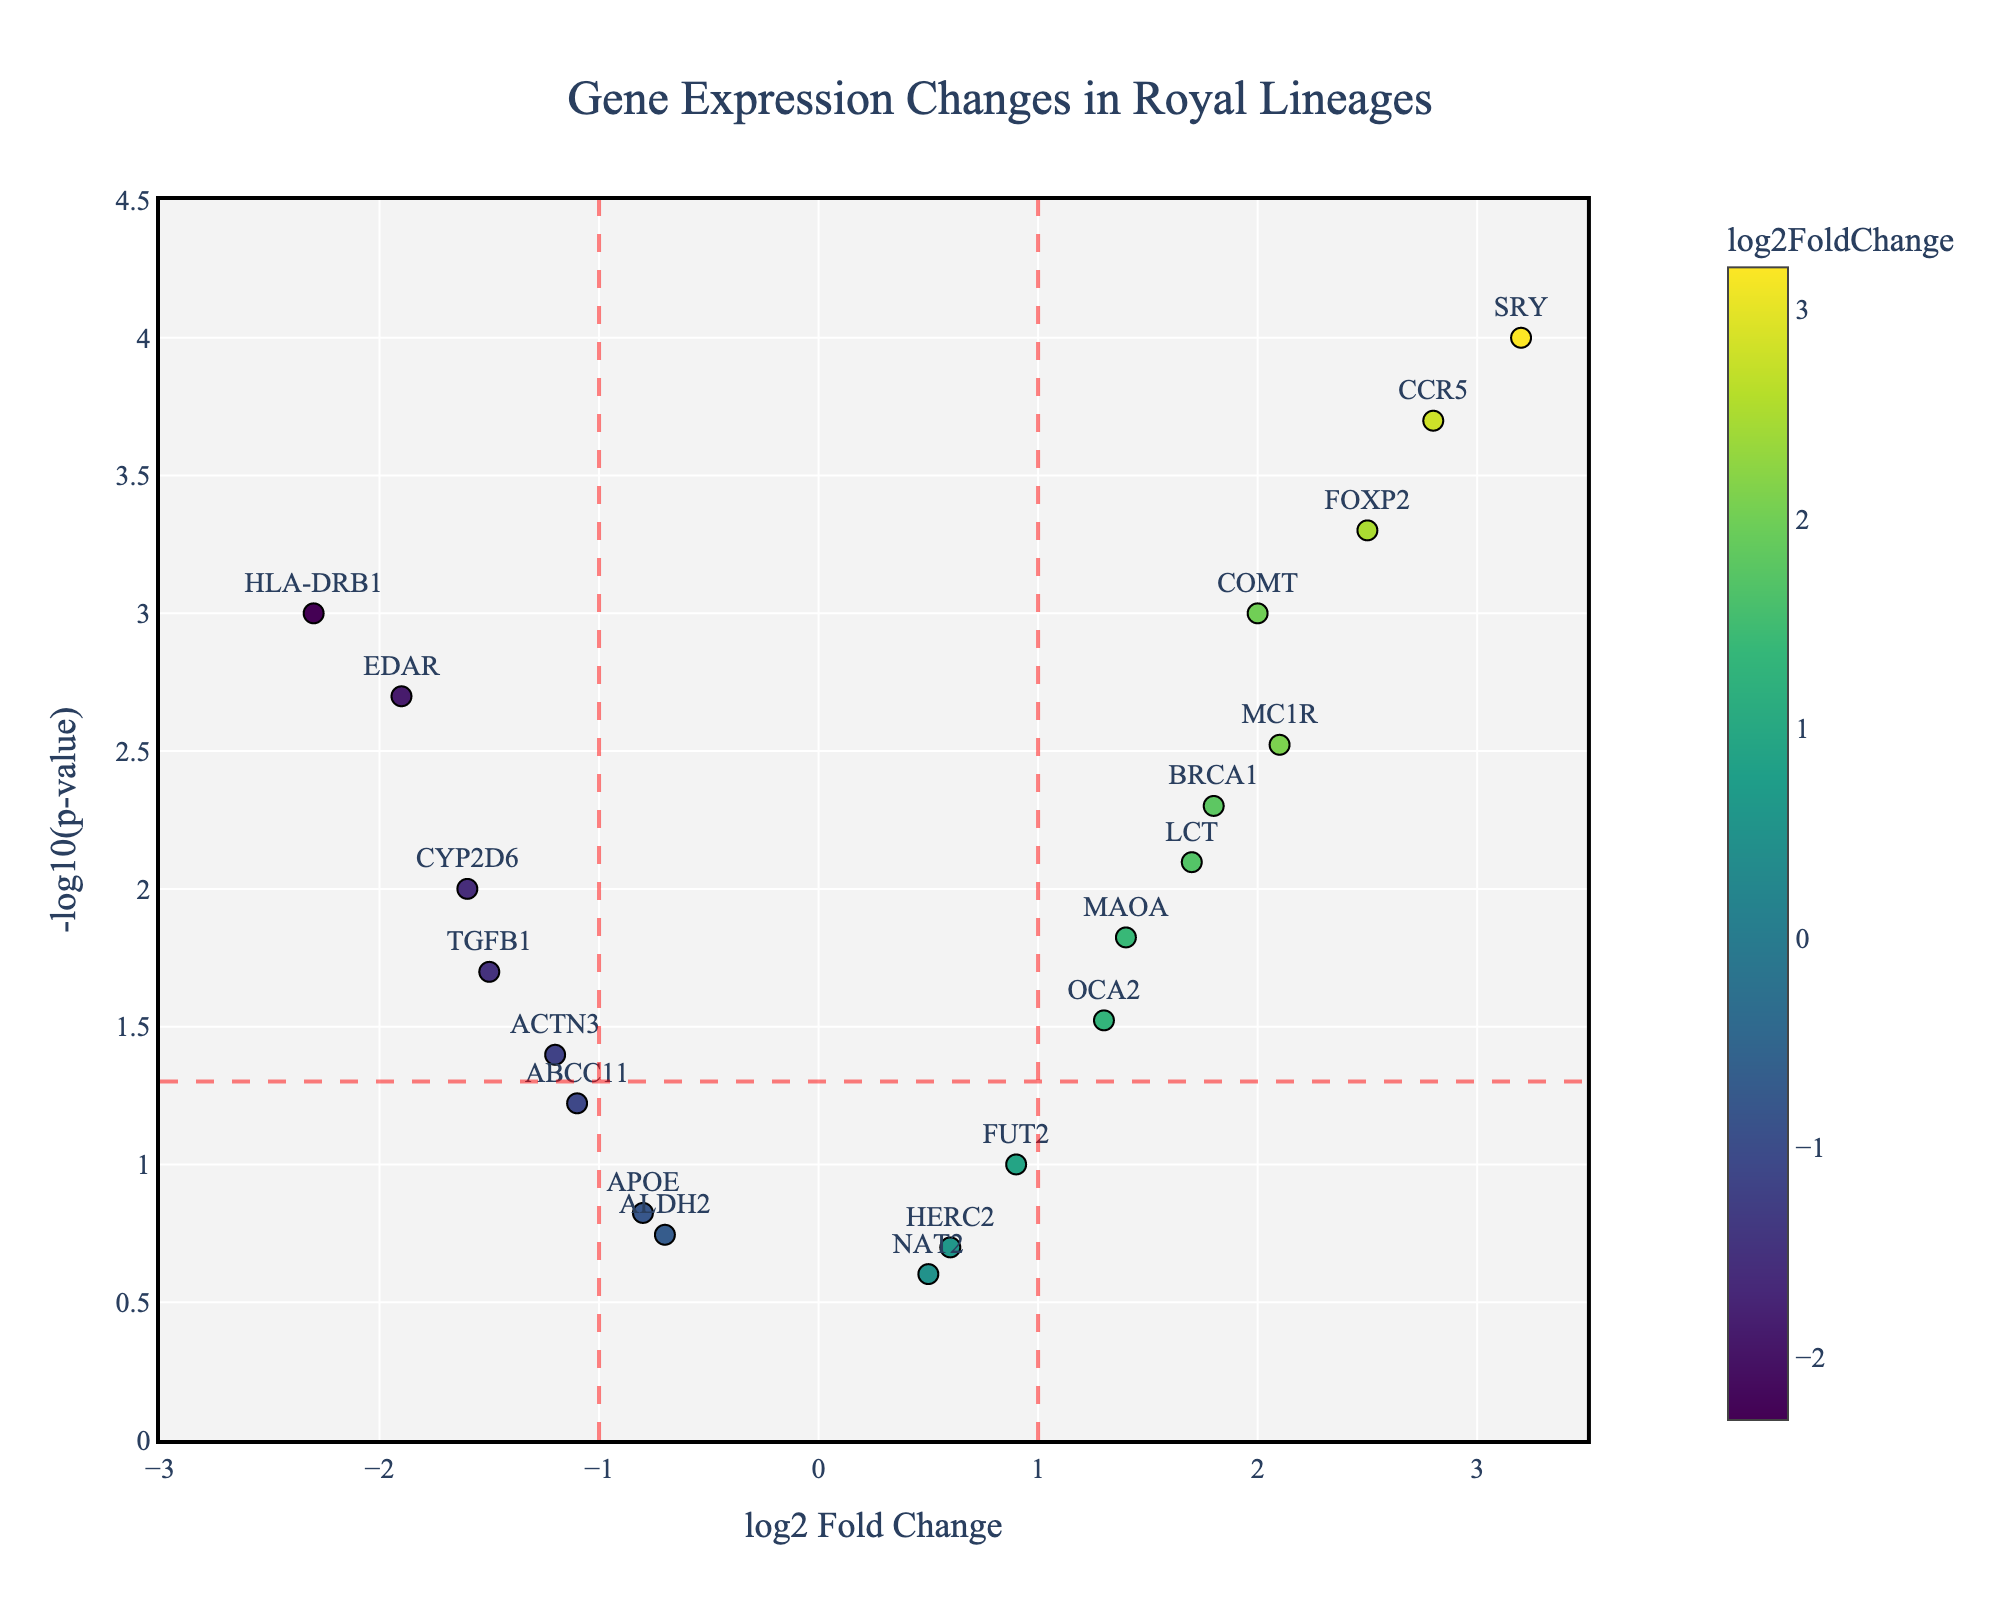What is the title of the plot? The title is usually displayed at the top center of the plot. In this figure, the title mentions "Gene Expression Changes in Royal Lineages".
Answer: Gene Expression Changes in Royal Lineages How many genes have a log2 fold change greater than 2? To answer this, we count the number of points (genes) with log2 fold change values (x-axis) greater than 2. The genes are represented by markers labeled by their names.
Answer: 4 (SRY, FOXP2, CCR5, and COMT) What color are the markers indicating downregulated genes? The downregulated genes have negative log2 fold change values, which correspond to a different color on the Viridis color scale. By referring to the colorbar, downregulated genes generally appear as darker blue colors.
Answer: Darker blue Which gene has the most statistically significant p-value and what is its -log10(p-value)? The most statistically significant p-value corresponds to the highest -log10(p-value) on the y-axis. By locating the highest point, we find the gene and its associated -log10(p-value). The highest point is labeled SRY.
Answer: SRY, 4 How many genes have a p-value less than 0.05 but a log2 fold change between -1 and 1? First, find the horizontal line marking the -log10(p-value) of 0.05. Then count the points within the vertical lines at -1 and 1 that lie above this horizontal line. These points are labeled HLA-DRB1, BRCA1, TGFB1, MC1R, LCT, EDAR, OCA2, MAOA, and CYP2D6.
Answer: 9 Which gene has the smallest log2 fold change and what is its p-value? By identifying the leftmost point on the x-axis (indicating the smallest log2 fold change) and checking its label and hovertext for the p-value, we find this gene.
Answer: HLA-DRB1, 0.001 Which genes are upregulated with a -log10(p-value) greater than 2.5? Upregulated genes have positive log2 fold changes. We locate the genes with y-axis values greater than 2.5 (above the horizontal line) with positive x-axis values. These genes are SRY, CCR5, and FOXP2.
Answer: SRY, CCR5, and FOXP2 What's the average log2 fold change for the genes with a log2 fold change greater than 1.5? Select the genes (SRY, BRCA1, MC1R, LCT, FOXP2, CCR5, COMT, MAOA) and sum their log2 fold change values, then divide by the count. (3.2 + 1.8 + 2.1 + 1.7 + 2.5 + 2.8 + 2.0 + 1.4) / 8 = 2.19
Answer: 2.19 Which gene has the smallest -log10(p-value) and what is its log2 fold change? The smallest -log10(p-value) corresponds to the lowest point on the y-axis (other than zero). By identifying this point and reading its label and the log2 fold change, we find this gene. The gene is APOE.
Answer: APOE, -0.8 